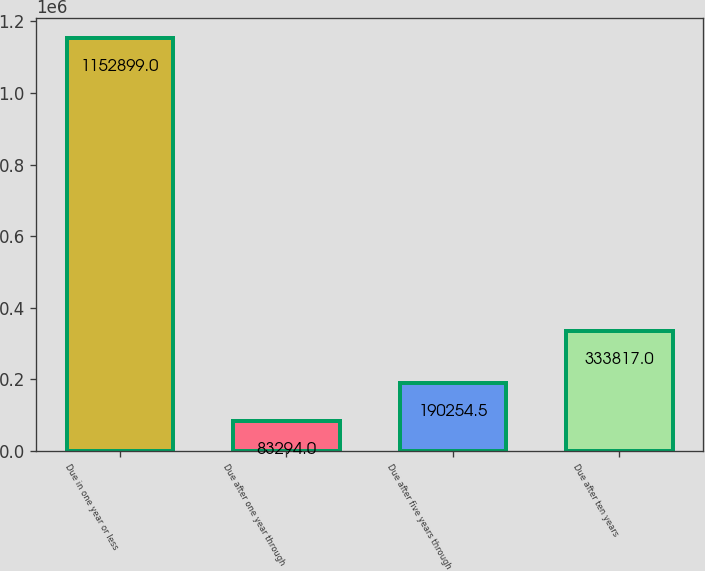Convert chart to OTSL. <chart><loc_0><loc_0><loc_500><loc_500><bar_chart><fcel>Due in one year or less<fcel>Due after one year through<fcel>Due after five years through<fcel>Due after ten years<nl><fcel>1.1529e+06<fcel>83294<fcel>190254<fcel>333817<nl></chart> 